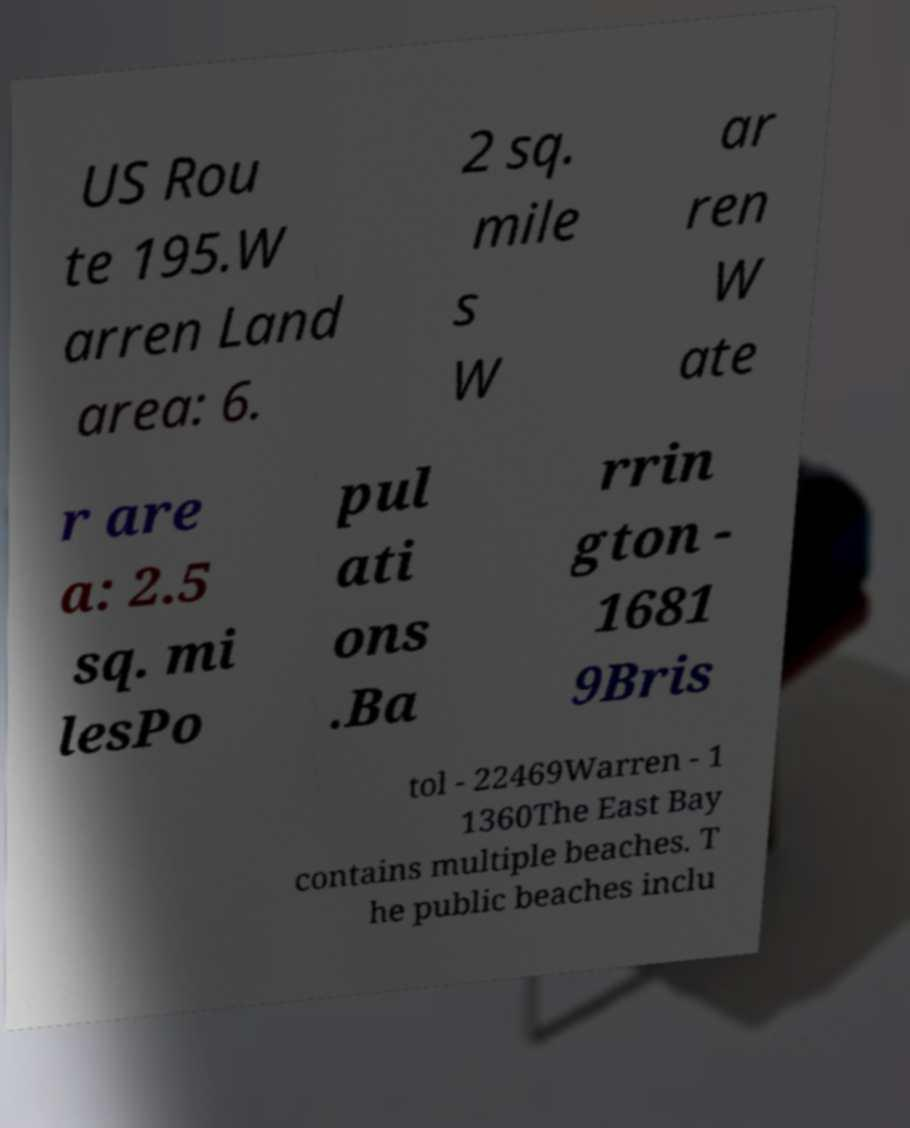For documentation purposes, I need the text within this image transcribed. Could you provide that? US Rou te 195.W arren Land area: 6. 2 sq. mile s W ar ren W ate r are a: 2.5 sq. mi lesPo pul ati ons .Ba rrin gton - 1681 9Bris tol - 22469Warren - 1 1360The East Bay contains multiple beaches. T he public beaches inclu 